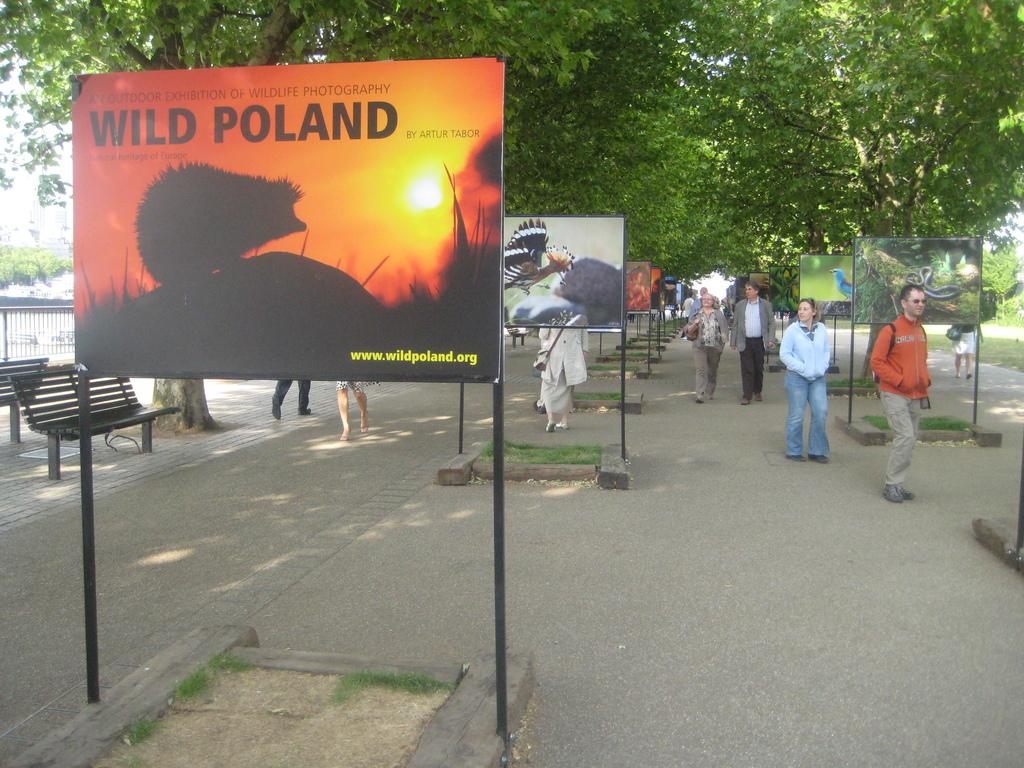What is written after the word wild on the sign?
Give a very brief answer. Poland. What link is shown in yellow on the wild poland board?
Give a very brief answer. Www.wildpoland.org. 